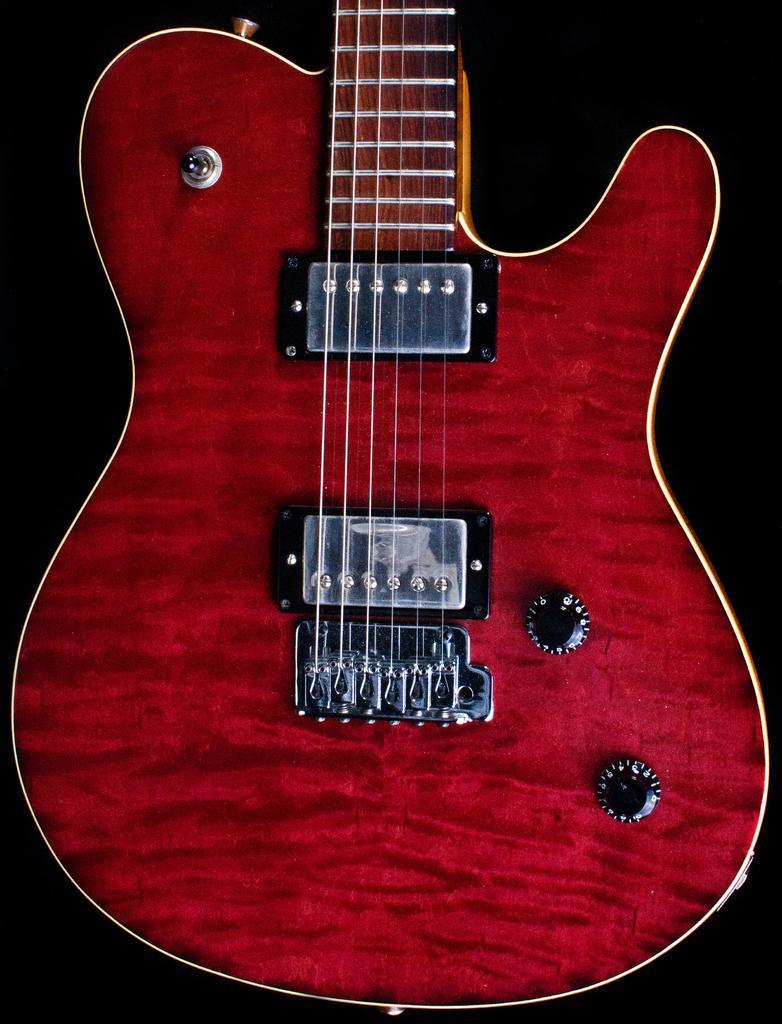In one or two sentences, can you explain what this image depicts? In this image I see a guitar, which is red and black in color. 